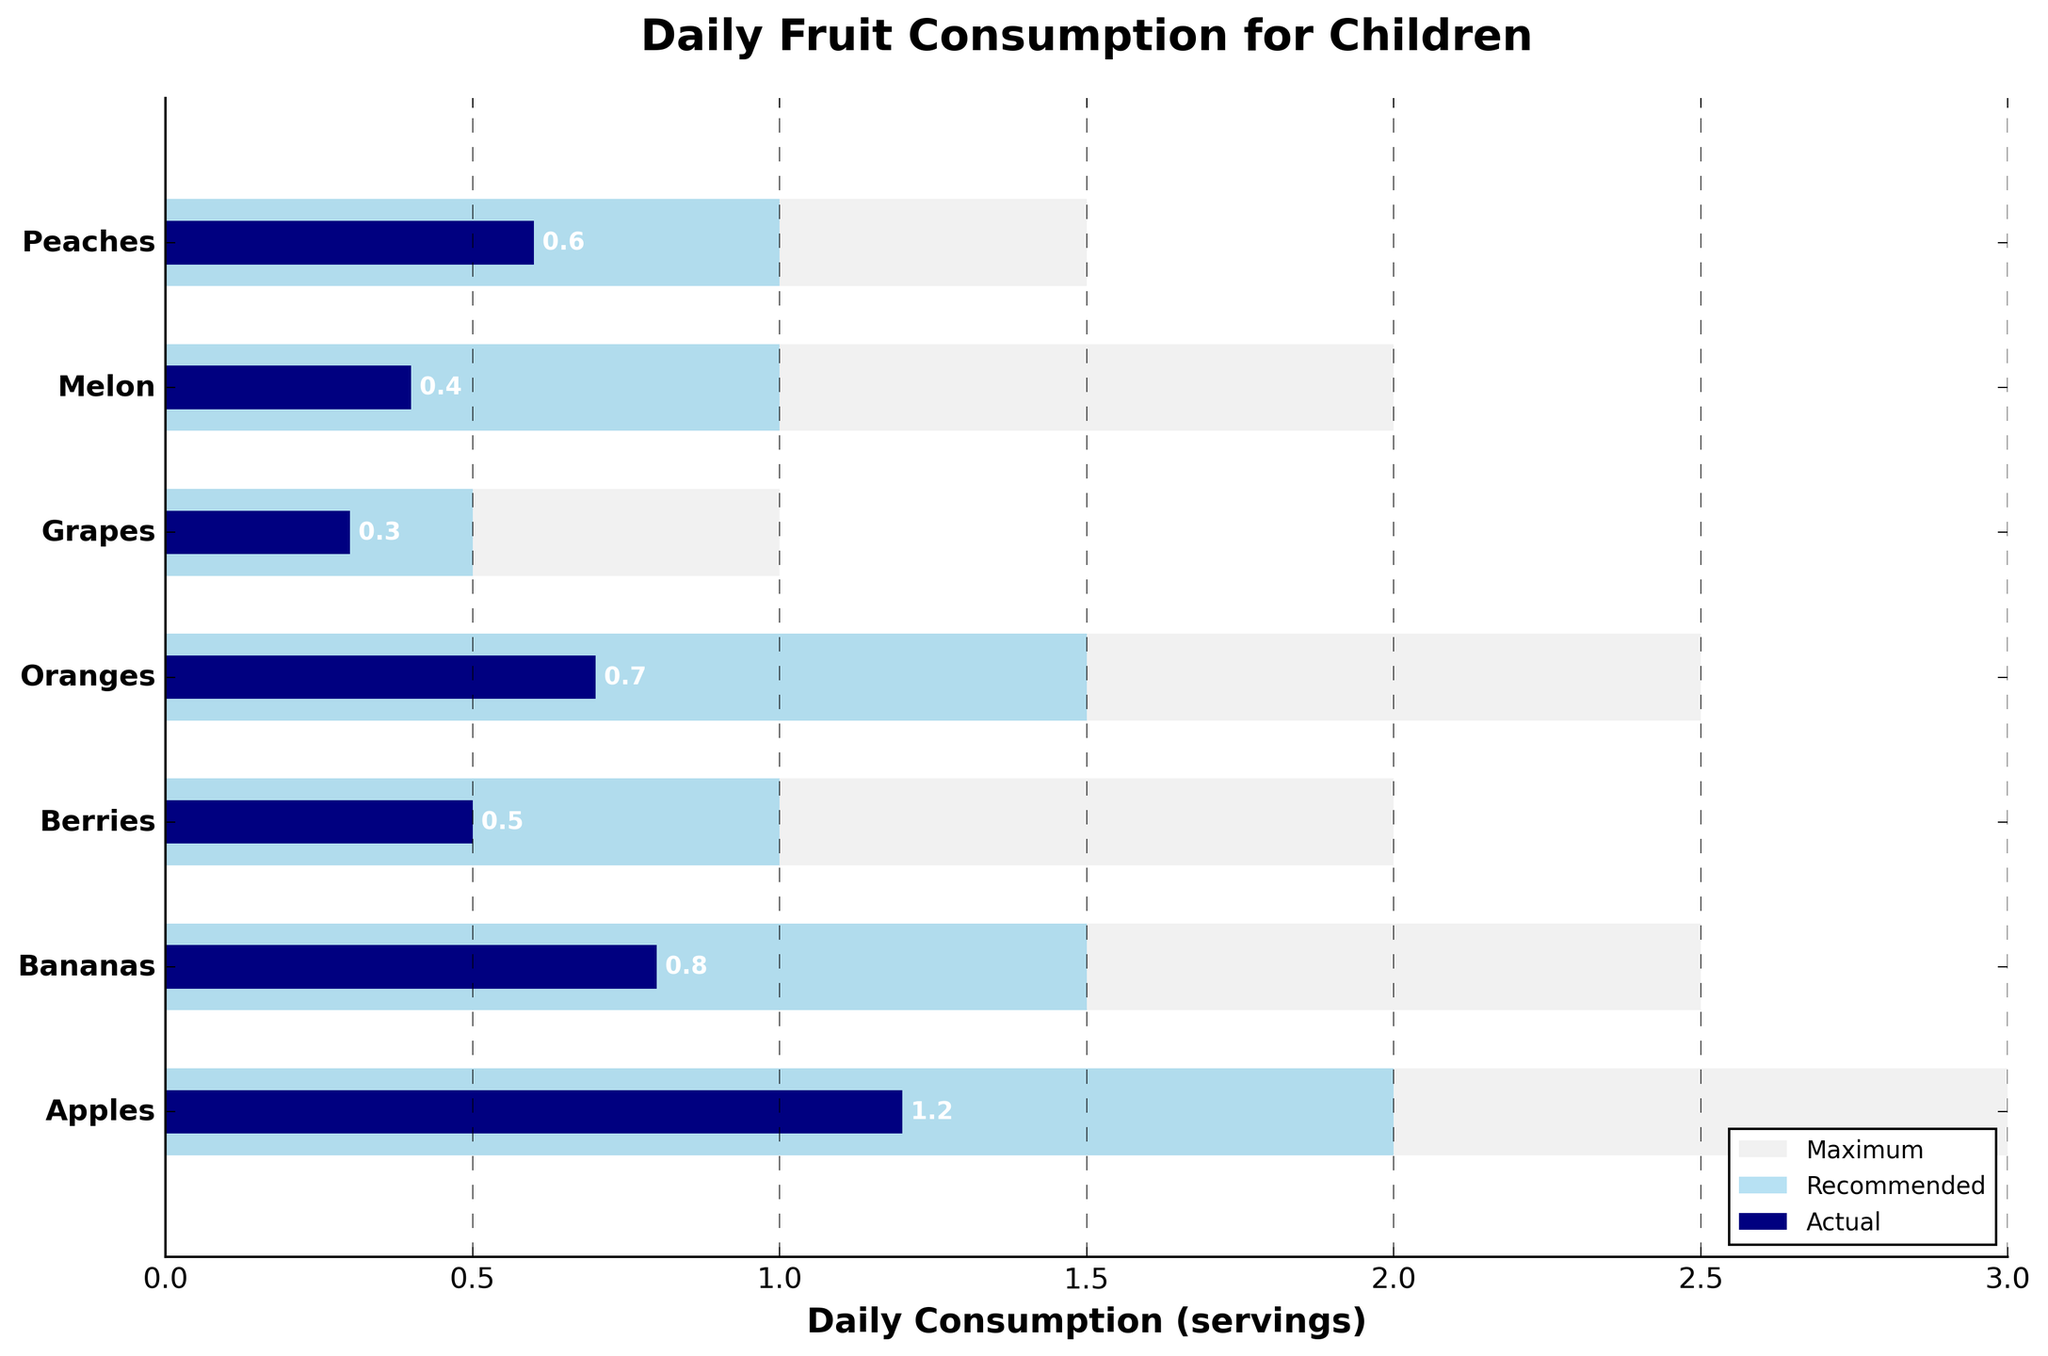What is the title of the chart? The title of the chart is displayed at the top center and it provides a summary of what the chart is about.
Answer: Daily Fruit Consumption for Children How many fruit categories are represented in the chart? Count the number of categories listed on the y-axis.
Answer: 7 Which fruit category has the highest actual daily consumption? Look for the longest dark blue bar, which represents actual consumption, and identify the corresponding fruit category.
Answer: Apples What is the recommended daily consumption for Bananas? Look for the light blue bar corresponding to Bananas and note its value along the x-axis.
Answer: 1.5 What is the difference between recommended and actual daily consumption of Oranges? Find the light blue and dark blue bars for Oranges, then subtract the value of the dark blue bar (actual) from the light blue bar (recommended).
Answer: 0.8 Which fruit category has the lowest actual daily consumption? Identify the shortest dark blue bar and check its corresponding fruit category.
Answer: Grapes Are any fruit categories meeting the recommended daily consumption? Compare the lengths of the dark blue (actual) and light blue (recommended) bars. If any dark blue bar meets or exceeds a light blue bar, that category meets the recommendation.
Answer: No How does the actual daily consumption of Grapes compare to the maximum recommended level? Compare the length of the dark blue bar (actual) to the length of the light grey bar (maximum) for Grapes. Determine if it is less, equal, or greater.
Answer: Less What is the total actual daily consumption of all the fruits combined? Sum the lengths of all the dark blue bars, which represent actual consumption for each fruit category.
Answer: 4.5 Which fruits have a recommended daily intake of 1 serving? Look for light blue bars that reach the 1-serving mark on the x-axis and note the corresponding fruit categories.
Answer: Berries, Melon, Peaches 